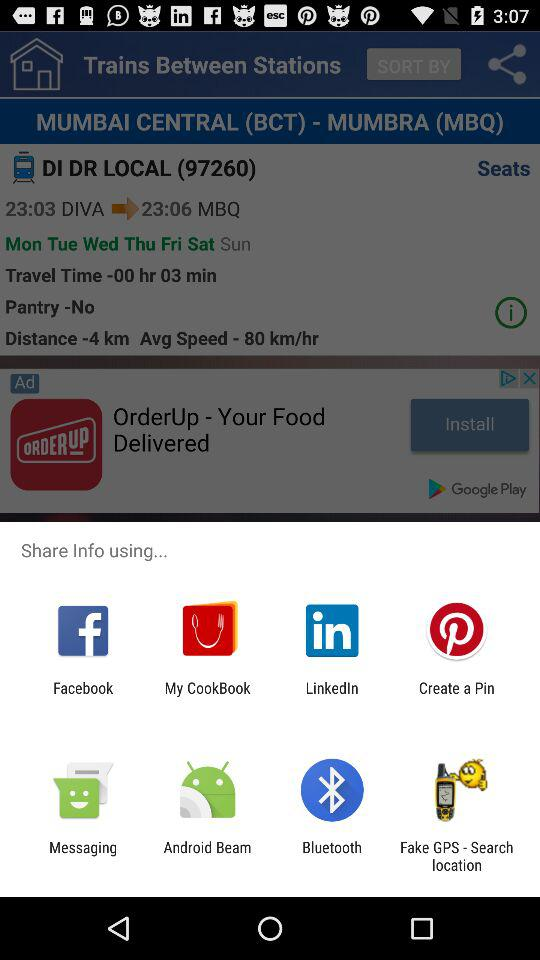How many minutes is the travel time for this train?
Answer the question using a single word or phrase. 3 